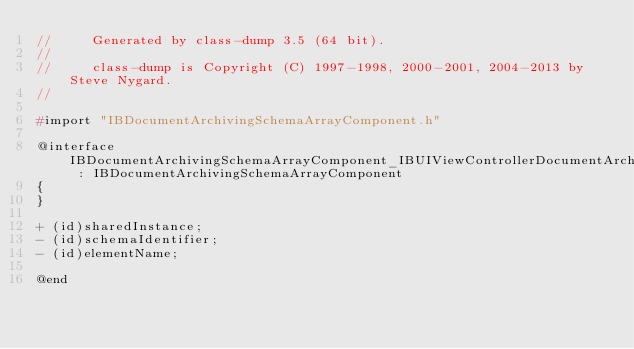Convert code to text. <code><loc_0><loc_0><loc_500><loc_500><_C_>//     Generated by class-dump 3.5 (64 bit).
//
//     class-dump is Copyright (C) 1997-1998, 2000-2001, 2004-2013 by Steve Nygard.
//

#import "IBDocumentArchivingSchemaArrayComponent.h"

@interface IBDocumentArchivingSchemaArrayComponent_IBUIViewControllerDocumentArchiving_toolbarItems : IBDocumentArchivingSchemaArrayComponent
{
}

+ (id)sharedInstance;
- (id)schemaIdentifier;
- (id)elementName;

@end

</code> 